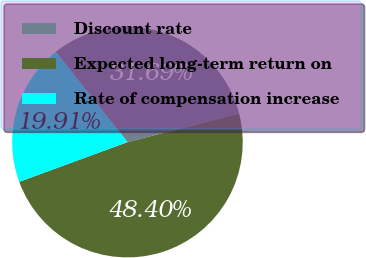<chart> <loc_0><loc_0><loc_500><loc_500><pie_chart><fcel>Discount rate<fcel>Expected long-term return on<fcel>Rate of compensation increase<nl><fcel>31.69%<fcel>48.4%<fcel>19.91%<nl></chart> 